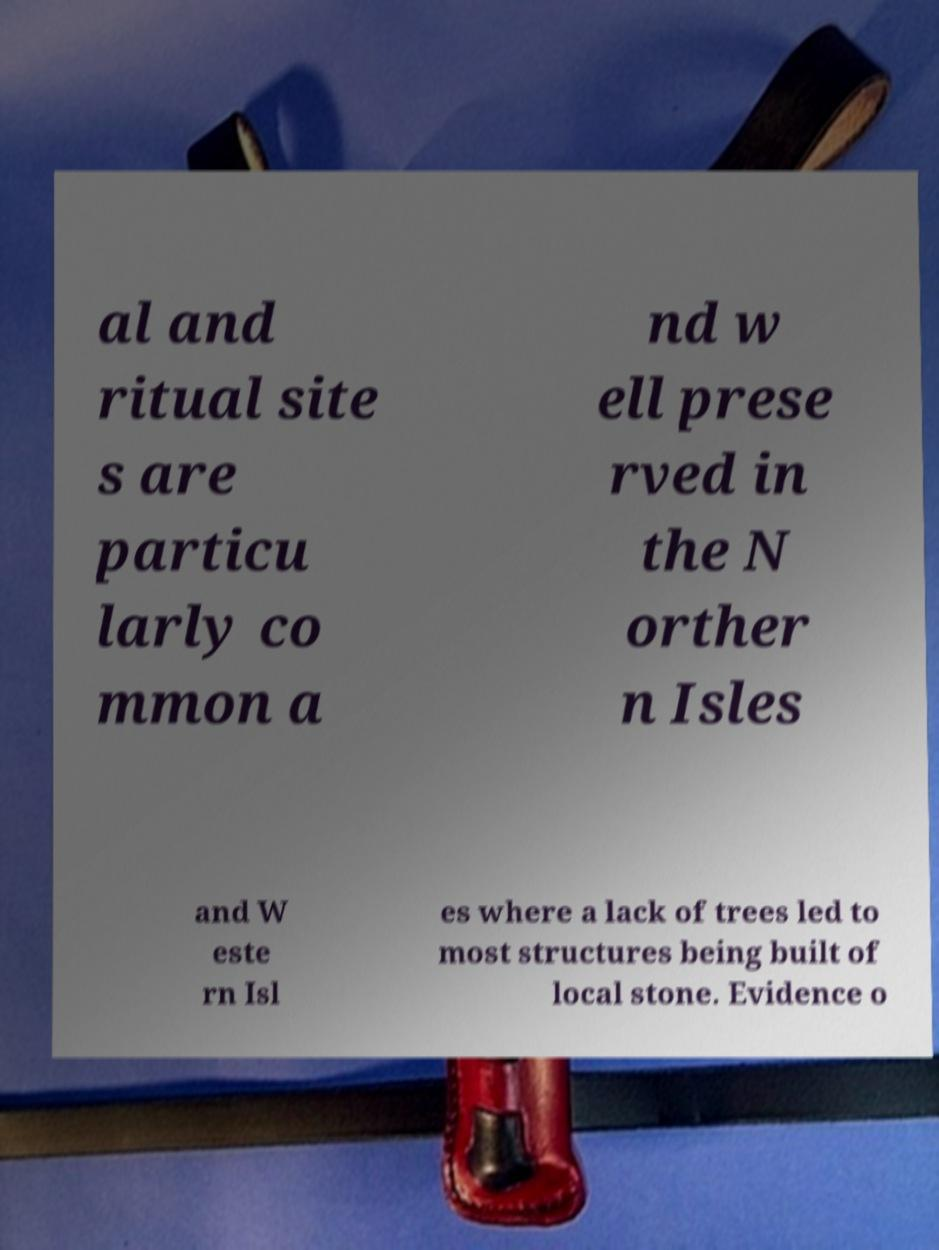For documentation purposes, I need the text within this image transcribed. Could you provide that? al and ritual site s are particu larly co mmon a nd w ell prese rved in the N orther n Isles and W este rn Isl es where a lack of trees led to most structures being built of local stone. Evidence o 